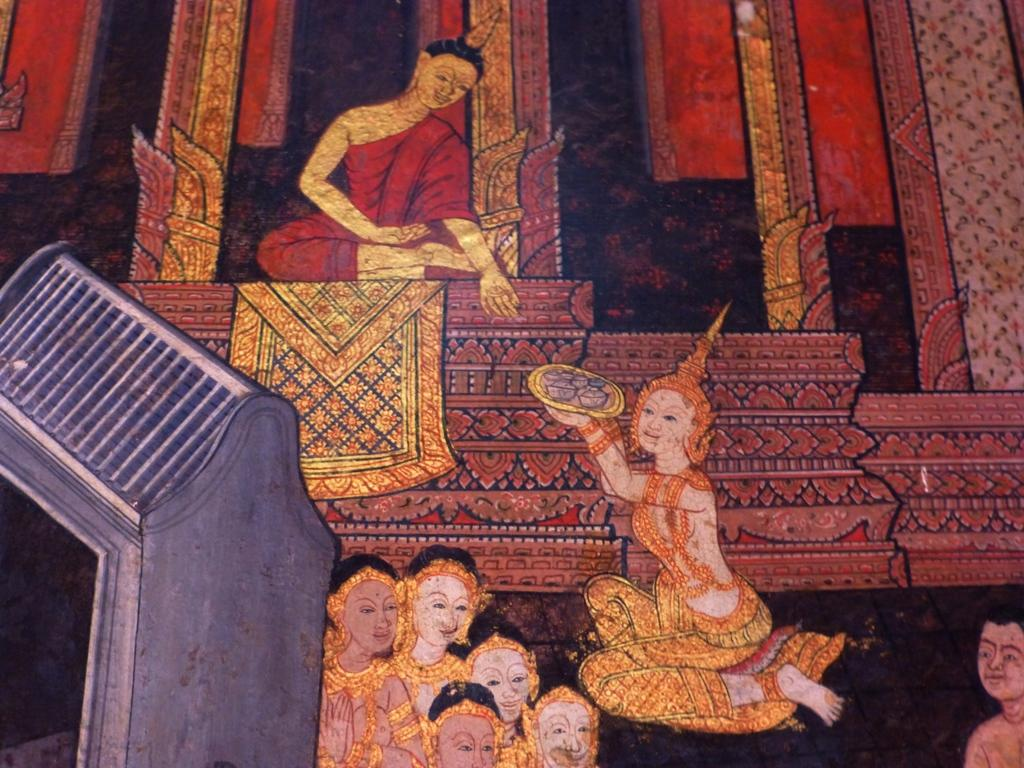What is the main subject of the image? The main subject of the image is a painting of persons. Can you describe any specific details about the painting? There is an object in gray color in the image. How does the painting help to melt the icicle in the image? There is no icicle present in the image, and the painting does not have the ability to affect its surroundings in that way. 